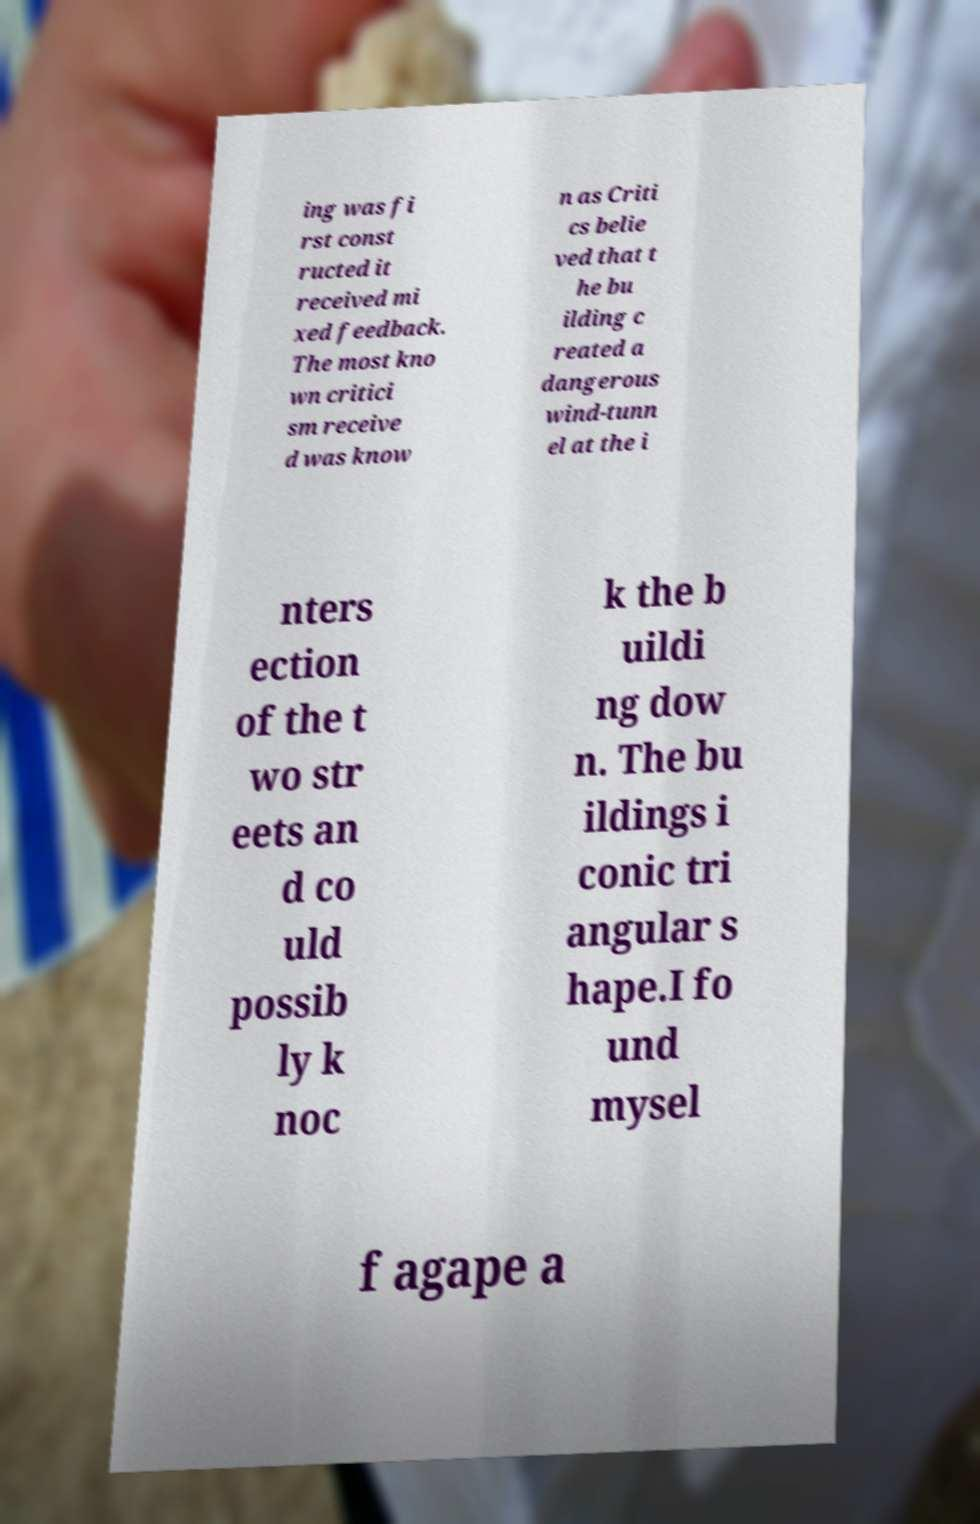Please identify and transcribe the text found in this image. ing was fi rst const ructed it received mi xed feedback. The most kno wn critici sm receive d was know n as Criti cs belie ved that t he bu ilding c reated a dangerous wind-tunn el at the i nters ection of the t wo str eets an d co uld possib ly k noc k the b uildi ng dow n. The bu ildings i conic tri angular s hape.I fo und mysel f agape a 